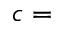<formula> <loc_0><loc_0><loc_500><loc_500>c =</formula> 